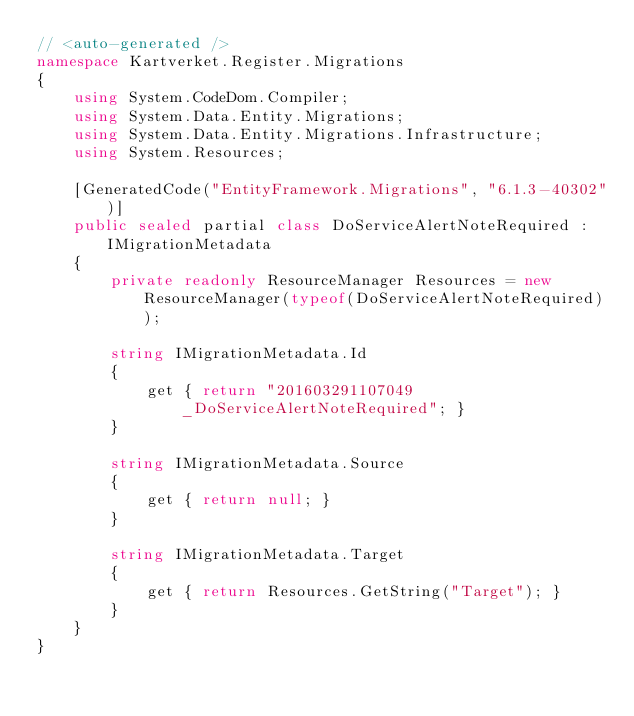Convert code to text. <code><loc_0><loc_0><loc_500><loc_500><_C#_>// <auto-generated />
namespace Kartverket.Register.Migrations
{
    using System.CodeDom.Compiler;
    using System.Data.Entity.Migrations;
    using System.Data.Entity.Migrations.Infrastructure;
    using System.Resources;
    
    [GeneratedCode("EntityFramework.Migrations", "6.1.3-40302")]
    public sealed partial class DoServiceAlertNoteRequired : IMigrationMetadata
    {
        private readonly ResourceManager Resources = new ResourceManager(typeof(DoServiceAlertNoteRequired));
        
        string IMigrationMetadata.Id
        {
            get { return "201603291107049_DoServiceAlertNoteRequired"; }
        }
        
        string IMigrationMetadata.Source
        {
            get { return null; }
        }
        
        string IMigrationMetadata.Target
        {
            get { return Resources.GetString("Target"); }
        }
    }
}
</code> 